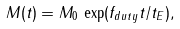<formula> <loc_0><loc_0><loc_500><loc_500>M ( t ) = M _ { 0 } \, \exp ( f _ { d u t y } { t / t _ { E } } ) ,</formula> 